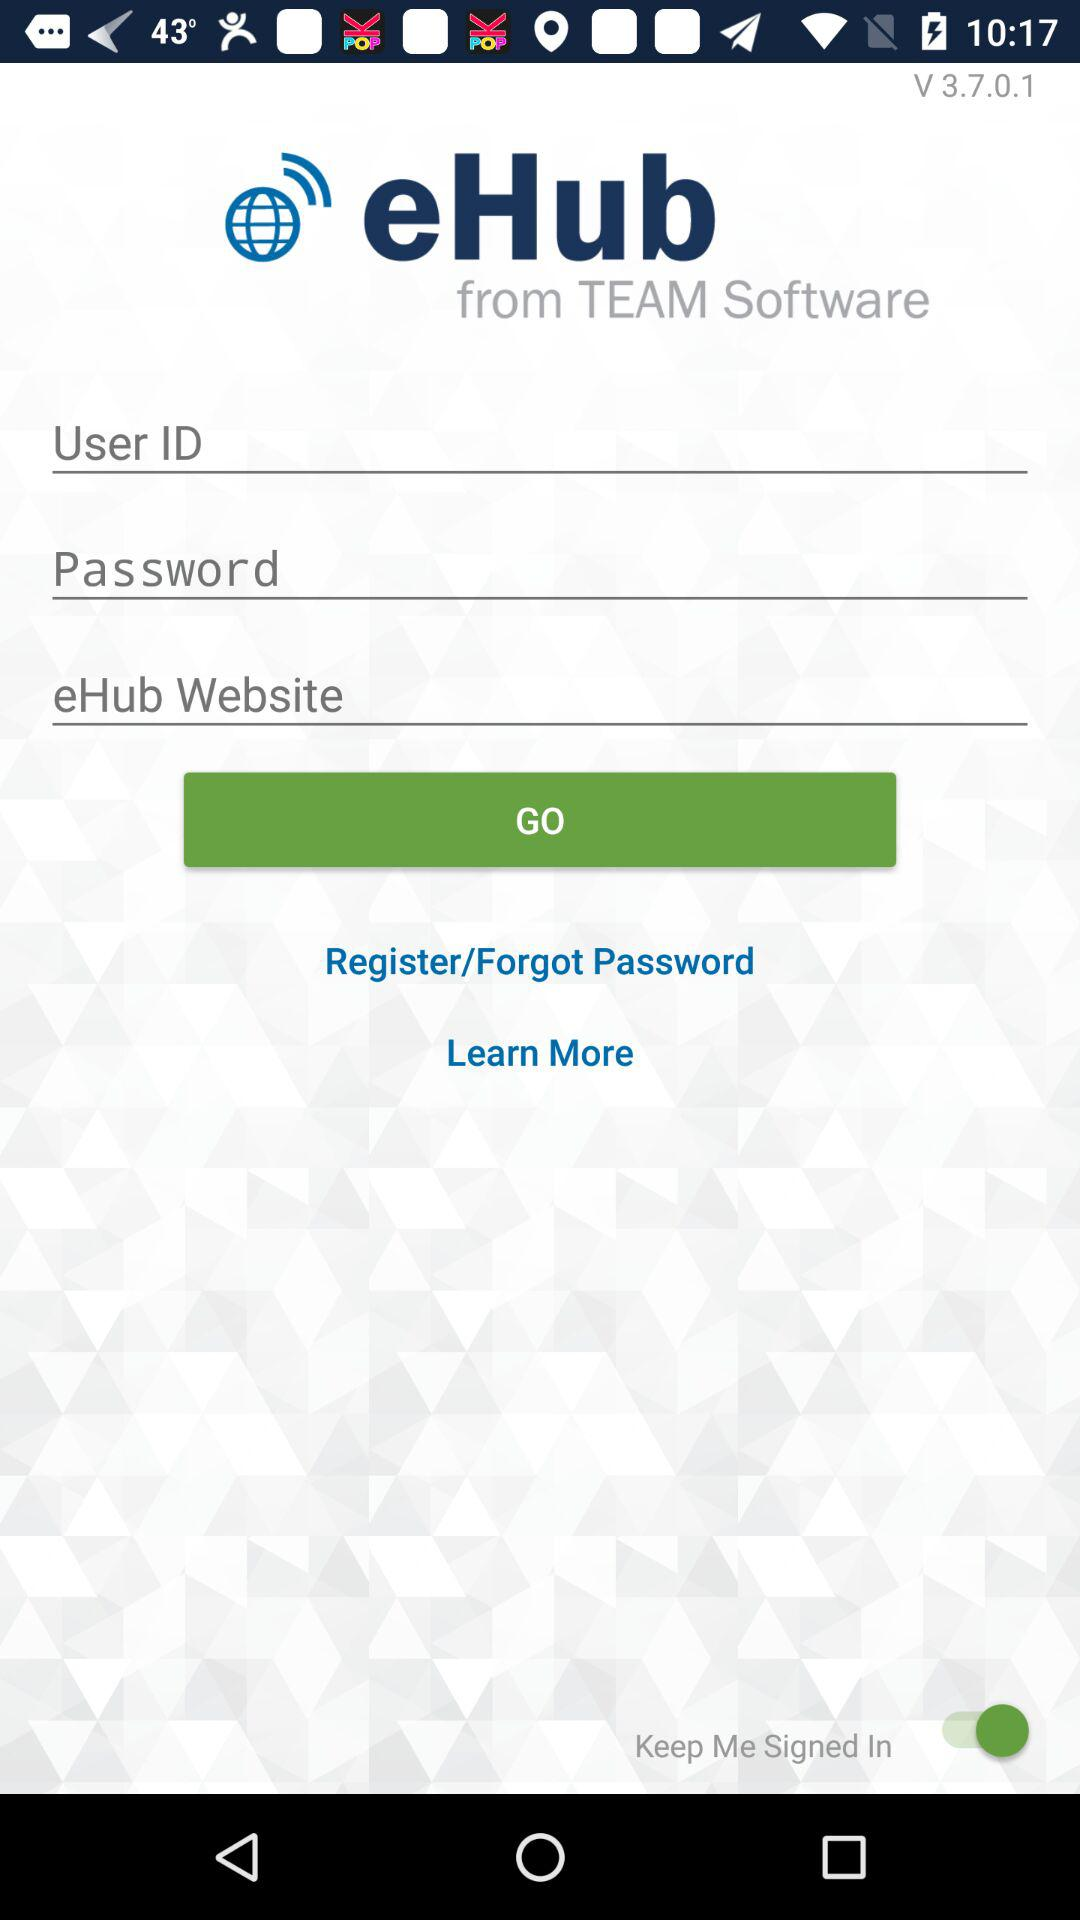What is the version of the app? The version of the app is V 3.7.0.1. 